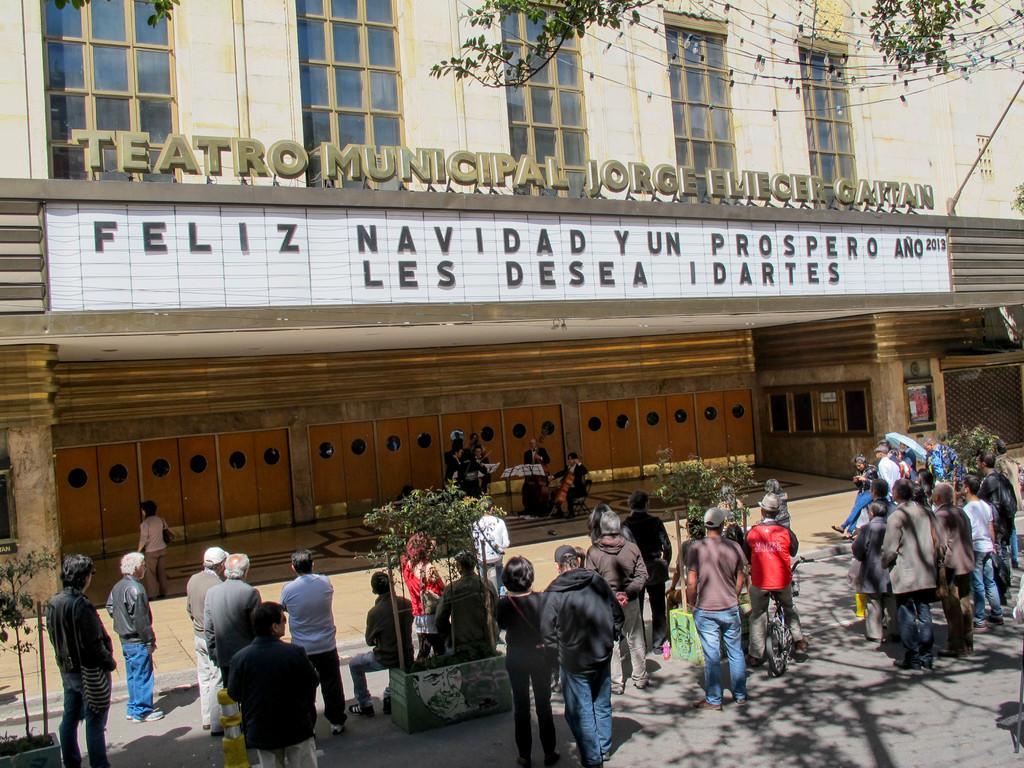Can you describe this image briefly? In this image there are group of people standing , a bicycle, plants, building, tree, rope light ,group of people standing and holding musical instruments, books on the stands. 